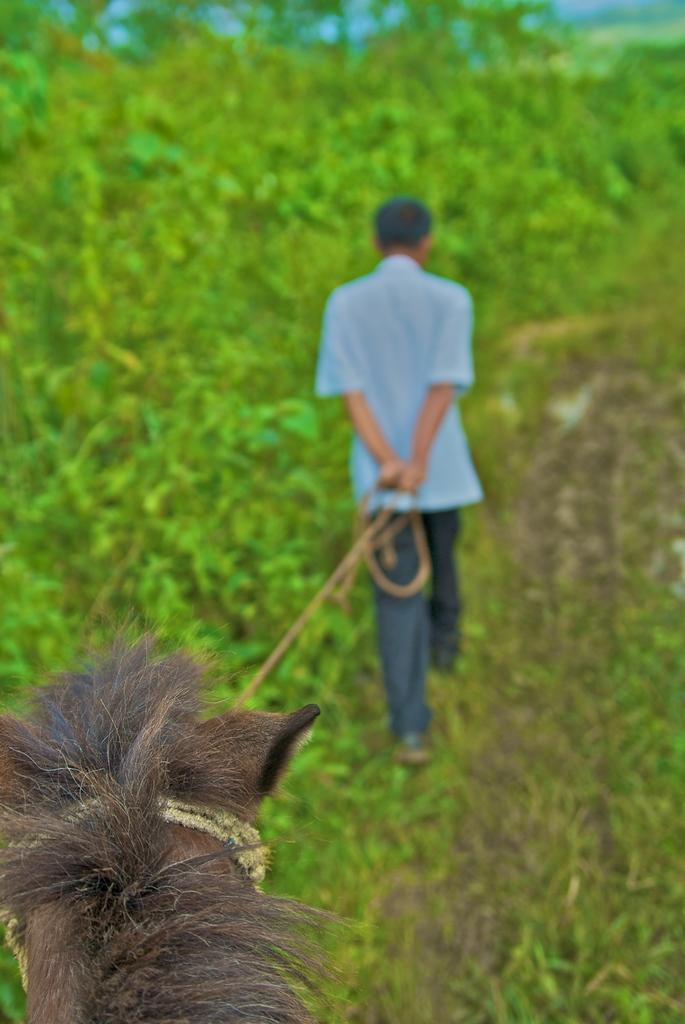Could you give a brief overview of what you see in this image? In the middle of the image we can see a man, he is holding an animal with the help of rope, beside him we can see trees. 